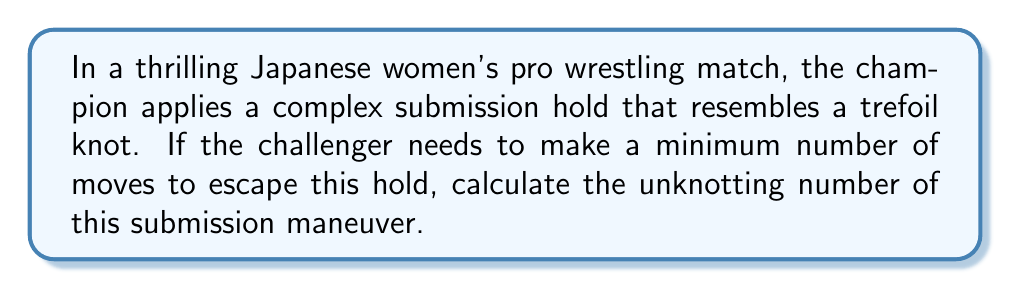Can you answer this question? To solve this problem, we need to understand the concept of unknotting number in knot theory and apply it to the trefoil knot:

1. The unknotting number of a knot is the minimum number of crossing changes required to transform the knot into an unknot (a simple loop).

2. The trefoil knot is one of the simplest non-trivial knots in knot theory.

3. For the trefoil knot, we can visualize it as follows:

[asy]
import geometry;

path p = (0,0)--(1,0)--(0.5,0.866)--(0,0);
path q = (0.5,0.289)--(1,0.577)--(0.5,0.866);

draw(p);
draw(q);

dot((0,0));
dot((1,0));
dot((0.5,0.866));
[/asy]

4. To unknot the trefoil, we need to change one of the crossings. This can be done in one move:

   a. Choose any of the three crossings.
   b. Change the selected crossing by passing the strand that was originally underneath to go over the other strand instead.

5. After this single crossing change, the knot can be deformed into a simple loop without any further crossing changes.

6. Therefore, the unknotting number of the trefoil knot is 1.

In the context of the wrestling submission hold, this means the challenger needs to make one fundamental move (equivalent to changing one crossing) to escape the hold.
Answer: 1 